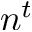Convert formula to latex. <formula><loc_0><loc_0><loc_500><loc_500>n ^ { t }</formula> 